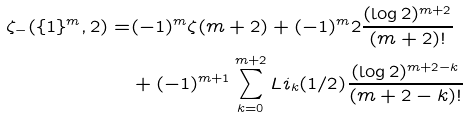Convert formula to latex. <formula><loc_0><loc_0><loc_500><loc_500>\zeta _ { - } ( \{ 1 \} ^ { m } , 2 ) = & ( - 1 ) ^ { m } \zeta ( m + 2 ) + ( - 1 ) ^ { m } 2 \frac { ( \log 2 ) ^ { m + 2 } } { ( m + 2 ) ! } \\ & + ( - 1 ) ^ { m + 1 } \sum _ { k = 0 } ^ { m + 2 } L i _ { k } ( 1 / 2 ) \frac { ( \log 2 ) ^ { m + 2 - k } } { ( m + 2 - k ) ! }</formula> 